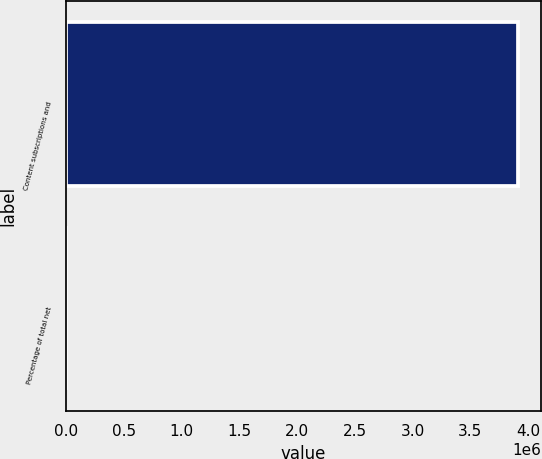Convert chart. <chart><loc_0><loc_0><loc_500><loc_500><bar_chart><fcel>Content subscriptions and<fcel>Percentage of total net<nl><fcel>3.91757e+06<fcel>75<nl></chart> 